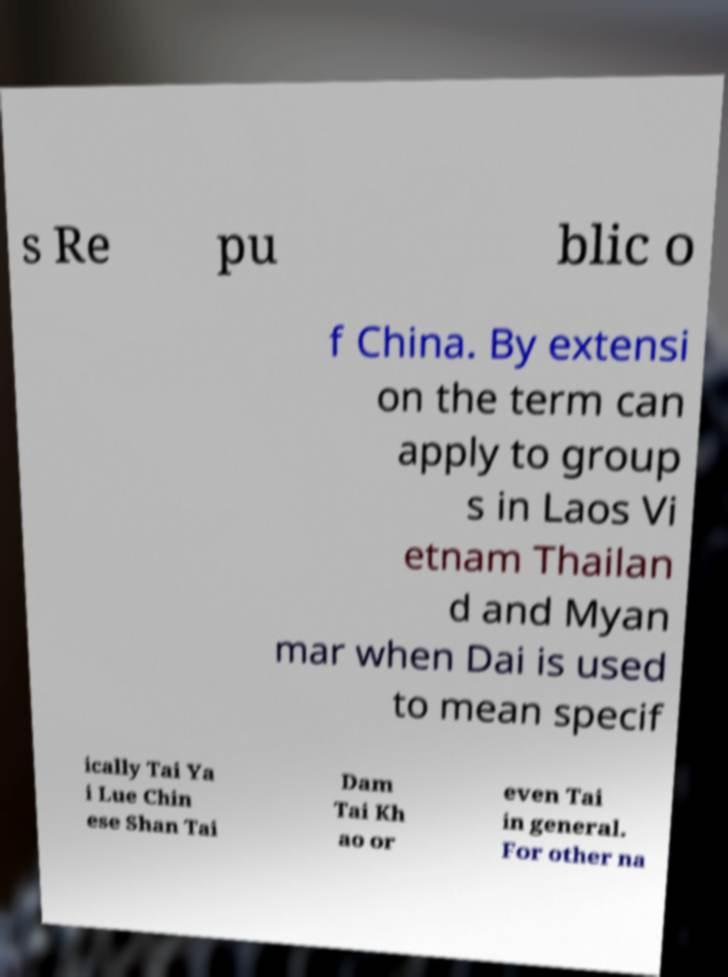Could you assist in decoding the text presented in this image and type it out clearly? s Re pu blic o f China. By extensi on the term can apply to group s in Laos Vi etnam Thailan d and Myan mar when Dai is used to mean specif ically Tai Ya i Lue Chin ese Shan Tai Dam Tai Kh ao or even Tai in general. For other na 